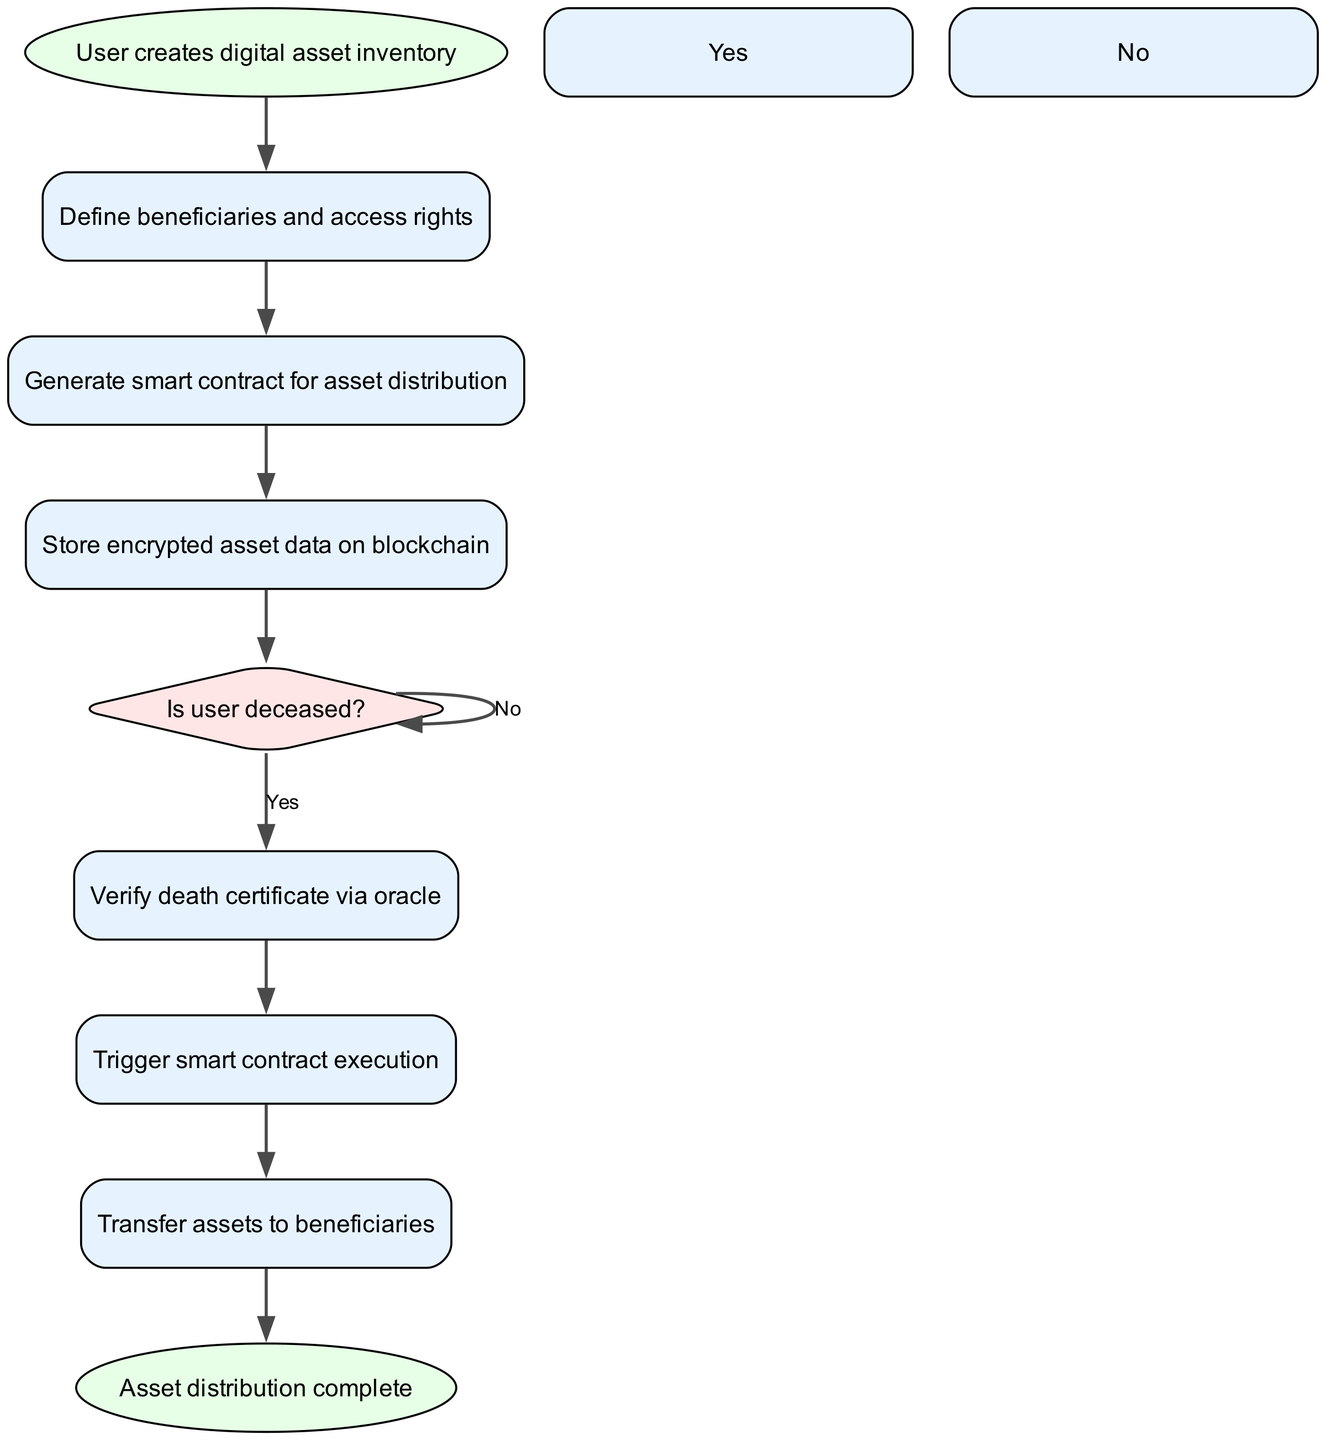What is the first step in the process? The first step is represented in the diagram as "User creates digital asset inventory," which is the starting point of the flowchart. This is the initial action before any decisions or steps are taken.
Answer: User creates digital asset inventory How many decision nodes are present in the diagram? There is a single decision node labeled "Is user deceased?" This node is crucial as it determines the subsequent steps based on the user's status.
Answer: 1 What is the final step in the process? The last step in the flowchart is "Asset distribution complete," indicating that the process concludes after transferring assets to beneficiaries.
Answer: Asset distribution complete What action follows after verifying the death certificate? After verifying the death certificate via oracle, the next action taken is to "Trigger smart contract execution." This step is essential to proceed with asset distribution upon confirmation of the user's death.
Answer: Trigger smart contract execution What happens if the user is not deceased? If the user is not deceased, the flowchart indicates a self-loop where the decision node "Is user deceased?" remains active, suggesting that until the user is confirmed deceased, no further actions in the process will occur.
Answer: No action Which step follows generating the smart contract? The step that follows generating the smart contract for asset distribution is "Store encrypted asset data on blockchain." This ensures that the asset details are securely recorded on the blockchain before any distribution can occur.
Answer: Store encrypted asset data on blockchain What process verifies the user's death? The process that verifies the user's death is through the step labeled "Verify death certificate via oracle." This mechanism ensures that a genuine verification occurs before moving to execute the smart contract.
Answer: Verify death certificate via oracle How many total steps are present in the diagram excluding the start and end? Excluding the start and end nodes, there are six steps outlined in the diagram, which consist of defining beneficiaries, generating a smart contract, storing asset data, verifying the death certificate, triggering the contract, and transferring assets.
Answer: 6 